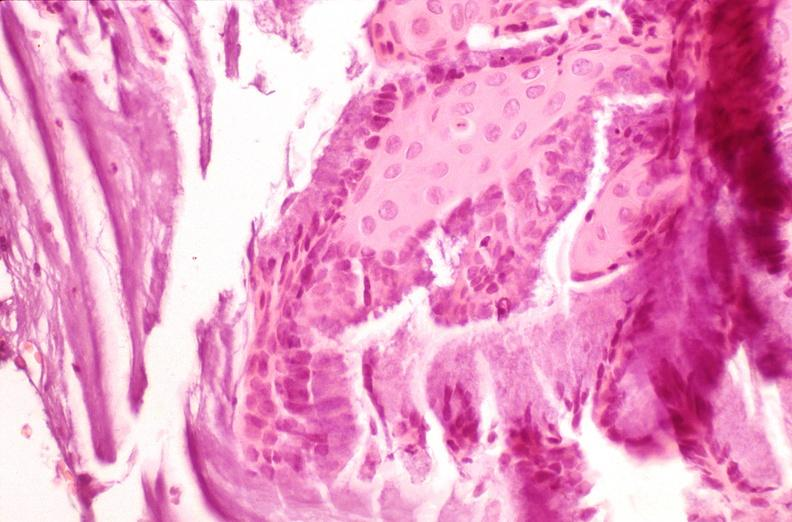s acute lymphocytic leukemia present?
Answer the question using a single word or phrase. No 